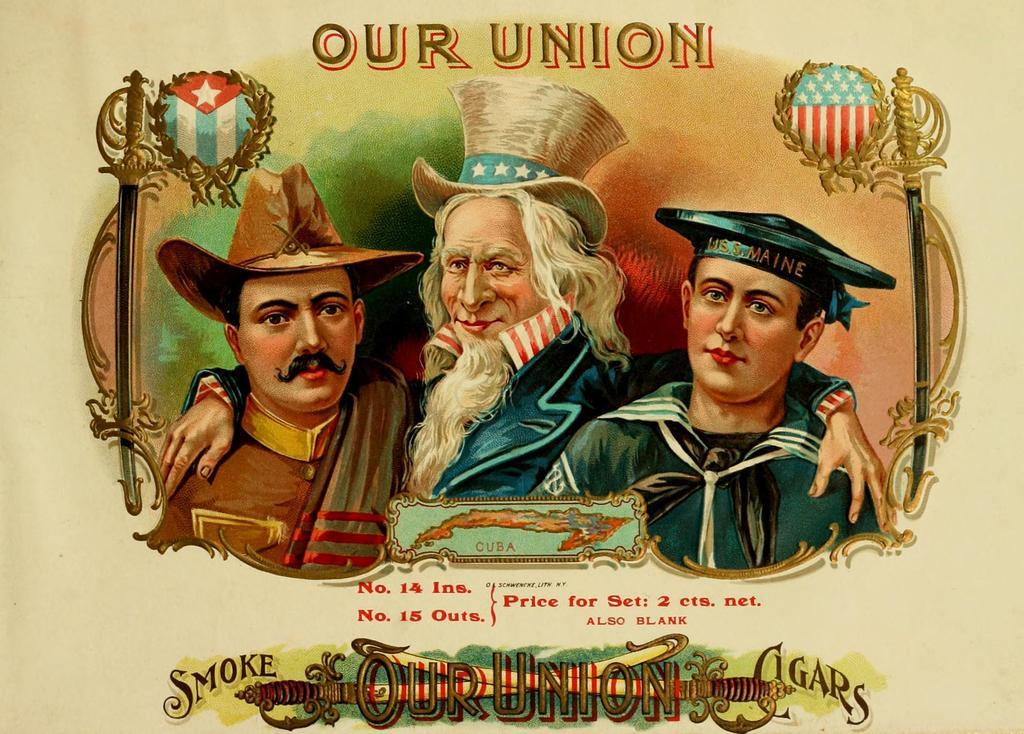How many people are in the image? There are three people in the image. What are the people wearing on their heads? The people are wearing caps. What can be seen on both sides of the image? There are two poles on both sides of the image. What is written on the poles? There is writing on the poles. What type of cord is being used by the clam in the image? There are no clams or cords present in the image. How many planes can be seen flying in the image? There are no planes visible in the image. 